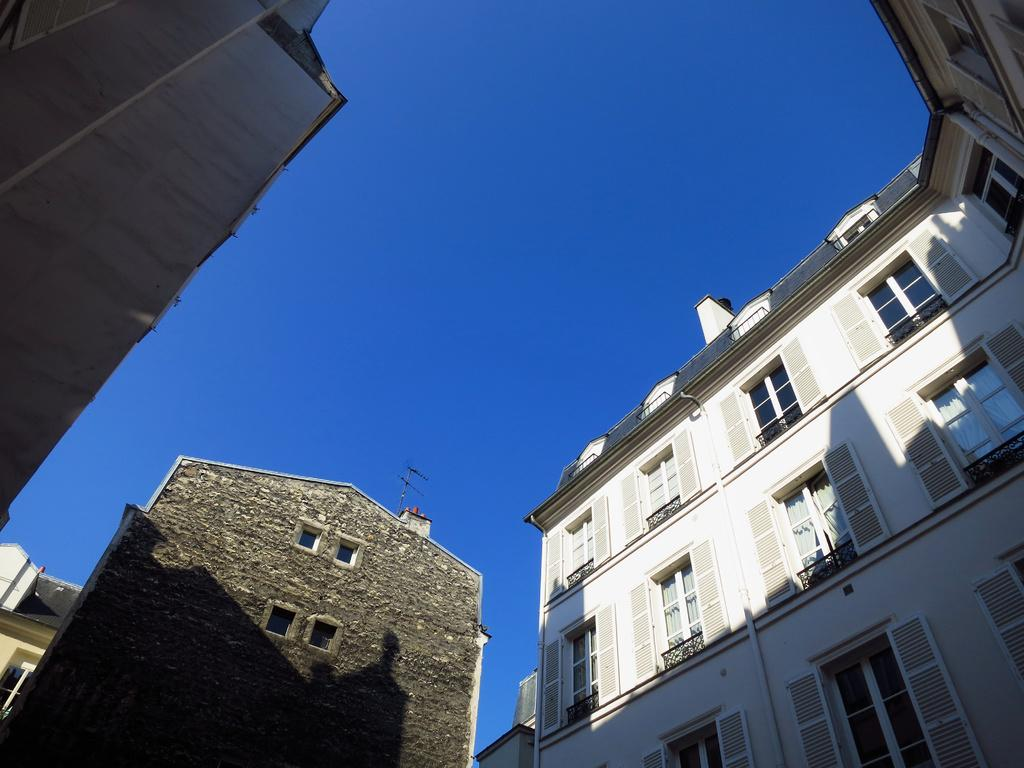What type of structures are visible in the image? There are buildings in the image. How do the buildings differ from one another? The buildings have different shapes and colors. From where was the image captured? The image was captured from the ground. What type of chain can be seen connecting the buildings in the image? There is no chain connecting the buildings in the image. What advice is given by the buildings in the image? Buildings do not give advice, as they are inanimate structures. 